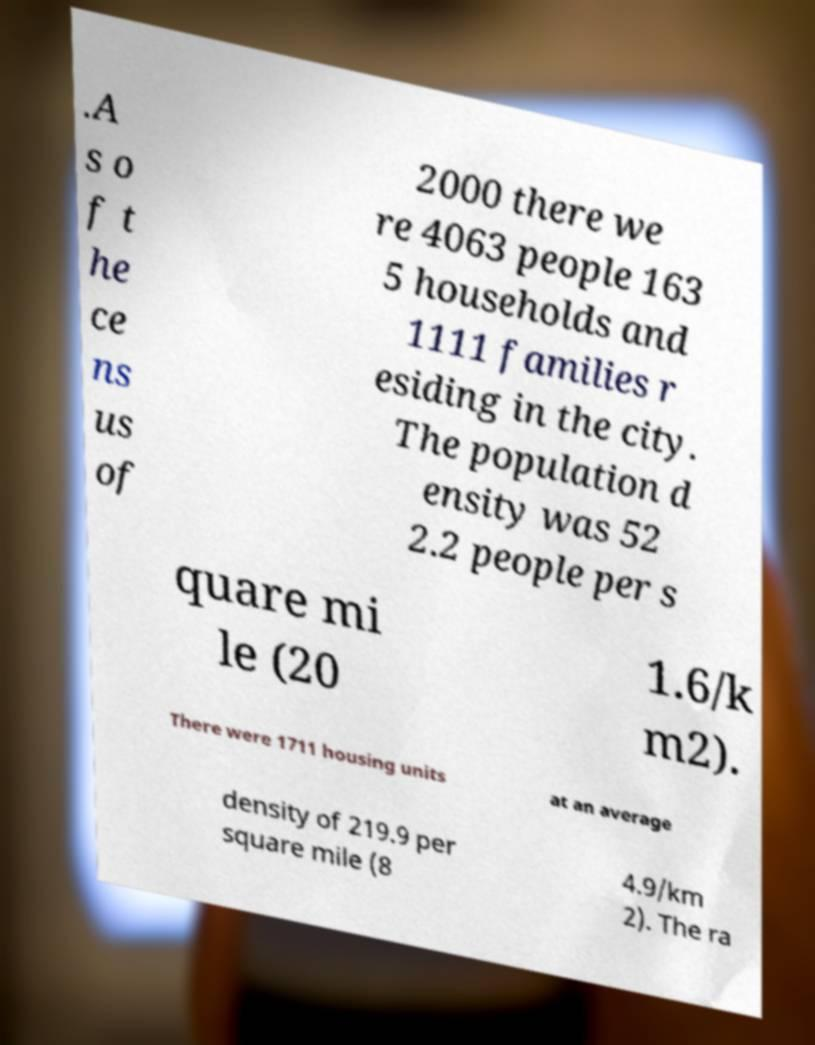There's text embedded in this image that I need extracted. Can you transcribe it verbatim? .A s o f t he ce ns us of 2000 there we re 4063 people 163 5 households and 1111 families r esiding in the city. The population d ensity was 52 2.2 people per s quare mi le (20 1.6/k m2). There were 1711 housing units at an average density of 219.9 per square mile (8 4.9/km 2). The ra 